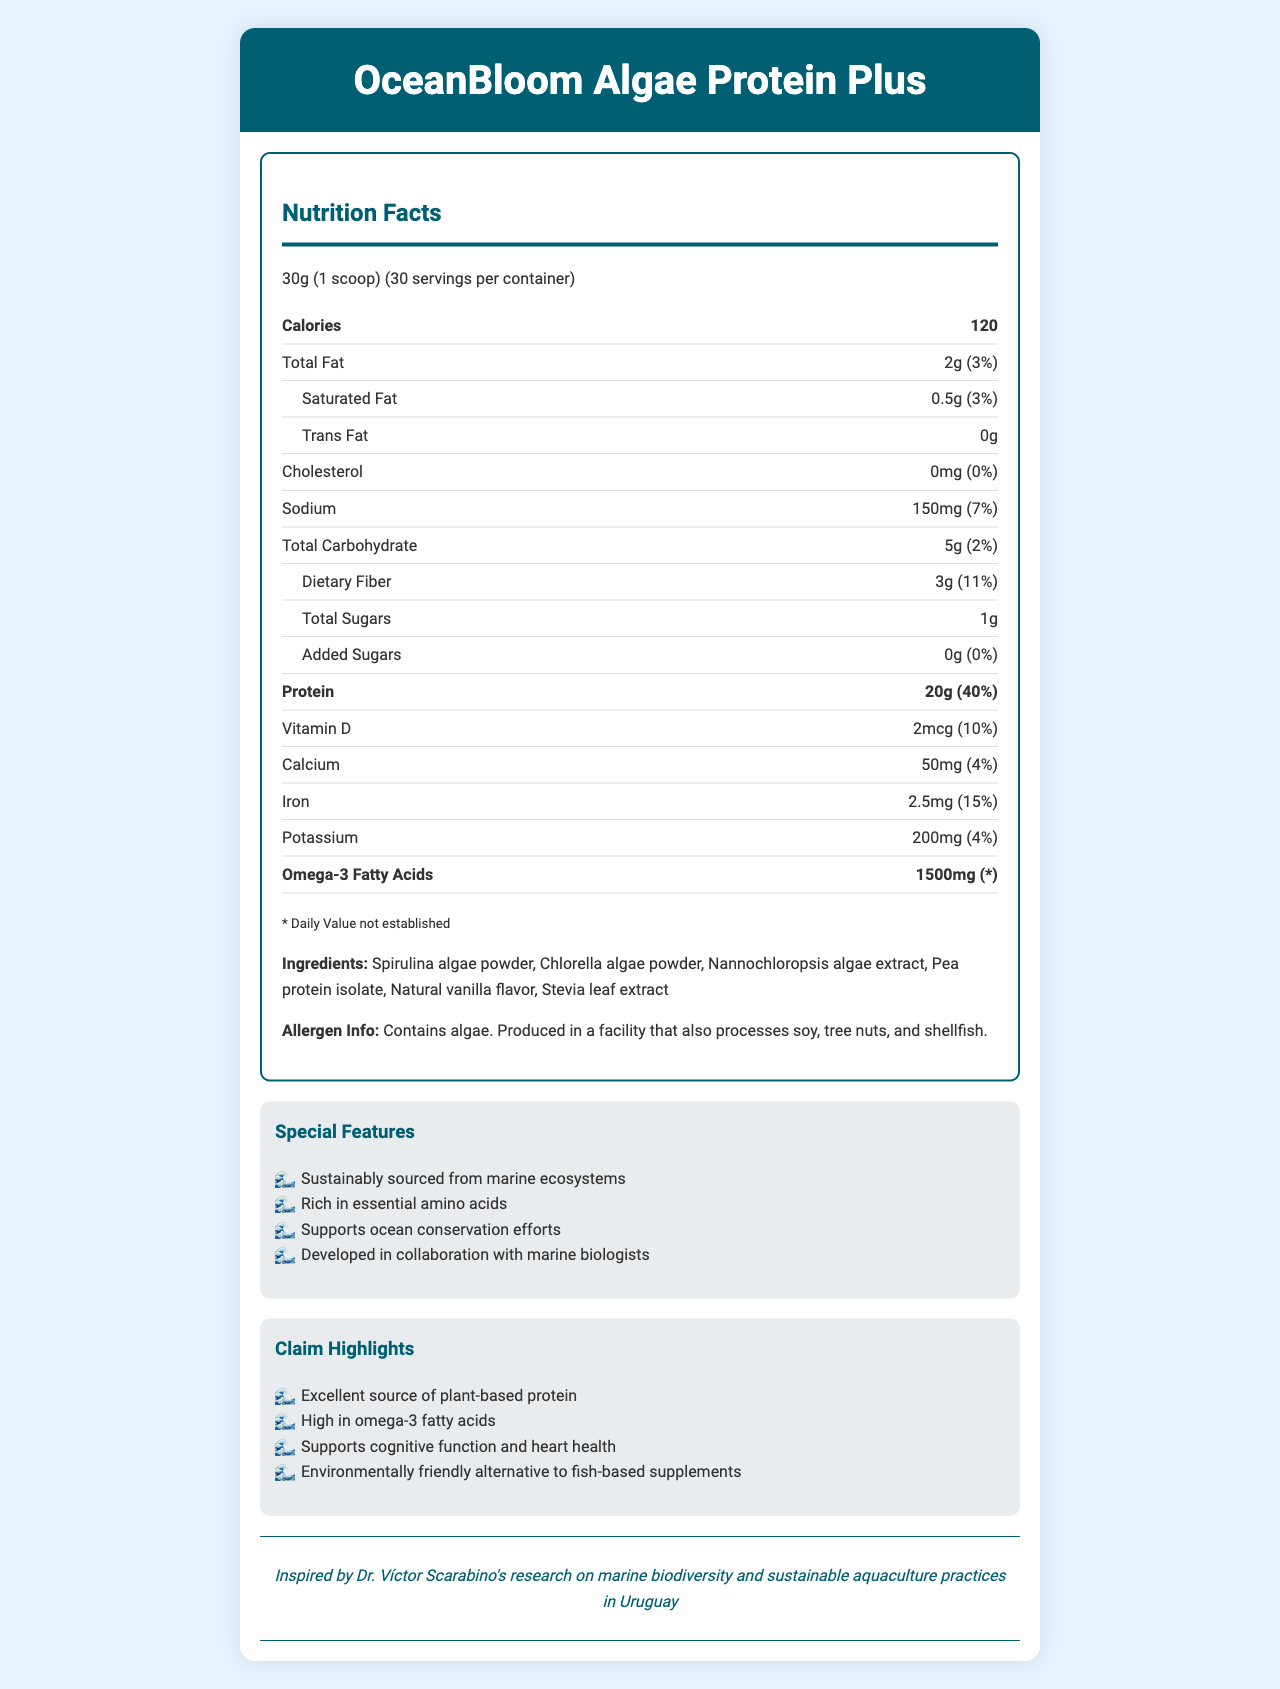what is the serving size? The serving size is mentioned at the beginning of the nutrition facts section as "30g (1 scoop)".
Answer: 30g (1 scoop) how many calories are in each serving? The calories per serving are listed clearly in the nutrition facts section as "Calories 120".
Answer: 120 calories what is the amount of protein per serving? The document mentions that there are 20g of protein per serving.
Answer: 20g how much omega-3 fatty acids does one serving contain? The amount of omega-3 fatty acids per serving is specified as 1500mg.
Answer: 1500mg what is the amount of sodium in one serving? The sodium content is listed as 150mg per serving.
Answer: 150mg which ingredient contributes to the vanilla flavor? A. Spirulina algae powder B. Chlorella algae powder C. Natural vanilla flavor The ingredient that gives the vanilla flavor is "Natural vanilla flavor".
Answer: C what is the daily value for dietary fiber in one serving? A. 11% B. 2% C. 7% D. 4% The daily value for dietary fiber is mentioned as 11%.
Answer: A is the supplement high in cholesterol? (Yes/No) The cholesterol content is 0mg, with a daily value of 0%, indicating it is not high in cholesterol.
Answer: No what is one special feature of this algae-based protein supplement? One of the special features listed is that it is "Sustainably sourced from marine ecosystems".
Answer: Sustainably sourced from marine ecosystems what claims are made about the product's environmental impact? One of the claim highlights is that the product is an "Environmentally friendly alternative to fish-based supplements".
Answer: Environmentally friendly alternative to fish-based supplements how does the product support ocean conservation? The document mentions in the special features section that the product "Supports ocean conservation efforts".
Answer: Supports ocean conservation efforts what insight did Dr. Víctor Scarabino provide for this product? The document states that the product was "Inspired by Dr. Víctor Scarabino's research on marine biodiversity and sustainable aquaculture practices in Uruguay".
Answer: Inspired by Dr. Víctor Scarabino's research on marine biodiversity and sustainable aquaculture practices in Uruguay what is the total carbohydrate content per serving? The total carbohydrate content per serving is 5g.
Answer: 5g how many servings are in one container? The container contains 30 servings, as mentioned in the serving size information.
Answer: 30 servings does the supplement contain any added sugars? The document states that there are 0g of added sugars per serving.
Answer: 0g is this product suitable for people with soy allergies? The document notes that it is produced in a facility that also processes soy, but does not explicitly state if the product itself contains soy.
Answer: Cannot be determined summarize the main features and facts about the OceanBloom Algae Protein Plus supplement. This question requires a comprehensive understanding of the entire document. It summarizes the key facts about the product's nutritional content, special features, claims, and development background.
Answer: The OceanBloom Algae Protein Plus is an algae-based protein supplement providing 20g of protein and 1500mg of omega-3 fatty acids per serving. Each serving contains 120 calories, 2g total fat, and other nutrients like vitamin D, calcium, and iron. It is sustainably sourced from marine ecosystems, rich in essential amino acids, and supports ocean conservation. The product is developed in collaboration with marine biologists and inspired by Dr. Víctor Scarabino's research. The ingredients include various algae powders, pea protein, vanilla flavor, and stevia leaf extract. It is produced in a facility that processes soy, tree nuts, and shellfish. 